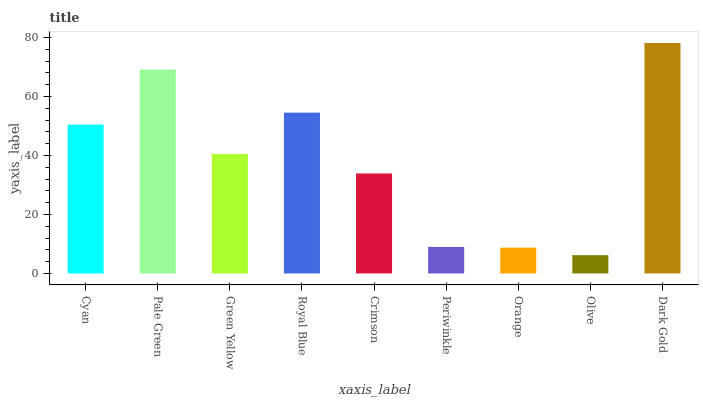Is Olive the minimum?
Answer yes or no. Yes. Is Dark Gold the maximum?
Answer yes or no. Yes. Is Pale Green the minimum?
Answer yes or no. No. Is Pale Green the maximum?
Answer yes or no. No. Is Pale Green greater than Cyan?
Answer yes or no. Yes. Is Cyan less than Pale Green?
Answer yes or no. Yes. Is Cyan greater than Pale Green?
Answer yes or no. No. Is Pale Green less than Cyan?
Answer yes or no. No. Is Green Yellow the high median?
Answer yes or no. Yes. Is Green Yellow the low median?
Answer yes or no. Yes. Is Olive the high median?
Answer yes or no. No. Is Crimson the low median?
Answer yes or no. No. 